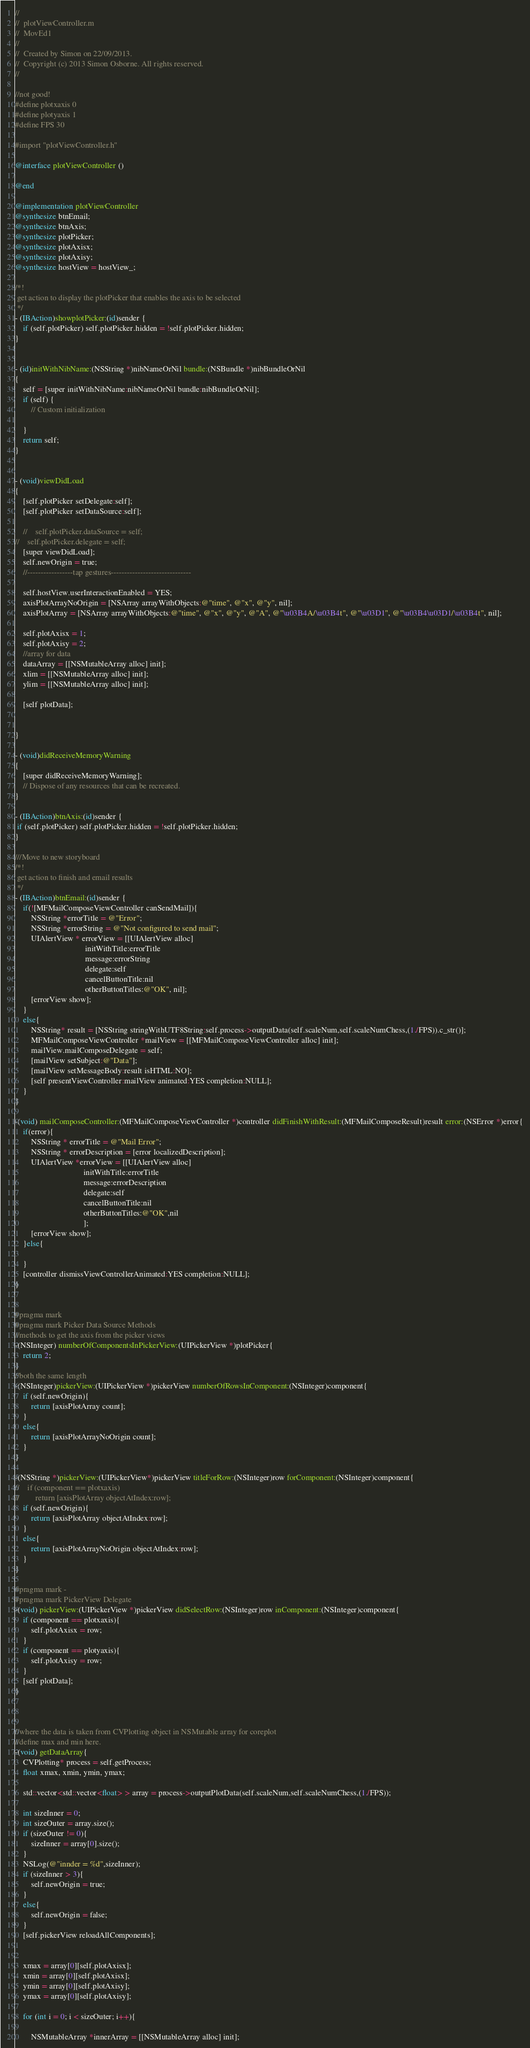<code> <loc_0><loc_0><loc_500><loc_500><_ObjectiveC_>//
//  plotViewController.m
//  MovEd1
//
//  Created by Simon on 22/09/2013.
//  Copyright (c) 2013 Simon Osborne. All rights reserved.
//

//not good!
#define plotxaxis 0
#define plotyaxis 1
#define FPS 30

#import "plotViewController.h"

@interface plotViewController ()

@end

@implementation plotViewController
@synthesize btnEmail;
@synthesize btnAxis;
@synthesize plotPicker;
@synthesize plotAxisx;
@synthesize plotAxisy;
@synthesize hostView = hostView_;

/*!
 get action to display the plotPicker that enables the axis to be selected
 */
- (IBAction)showplotPicker:(id)sender {
    if (self.plotPicker) self.plotPicker.hidden = !self.plotPicker.hidden;
}


- (id)initWithNibName:(NSString *)nibNameOrNil bundle:(NSBundle *)nibBundleOrNil
{
    self = [super initWithNibName:nibNameOrNil bundle:nibBundleOrNil];
    if (self) {
        // Custom initialization

    }
    return self;
}


- (void)viewDidLoad
{
    [self.plotPicker setDelegate:self];
    [self.plotPicker setDataSource:self];

    //    self.plotPicker.dataSource = self;
//    self.plotPicker.delegate = self;
    [super viewDidLoad];
    self.newOrigin = true;
    //-----------------tap gestures------------------------------
    
    self.hostView.userInteractionEnabled = YES;
    axisPlotArrayNoOrigin = [NSArray arrayWithObjects:@"time", @"x", @"y", nil];
    axisPlotArray = [NSArray arrayWithObjects:@"time", @"x", @"y", @"A", @"\u03B4A/\u03B4t", @"\u03D1", @"\u03B4\u03D1/\u03B4t", nil];
    
    self.plotAxisx = 1;
    self.plotAxisy = 2;
    //array for data
    dataArray = [[NSMutableArray alloc] init];
    xlim = [[NSMutableArray alloc] init];
    ylim = [[NSMutableArray alloc] init];

    [self plotData];
    

}

- (void)didReceiveMemoryWarning
{
    [super didReceiveMemoryWarning];
    // Dispose of any resources that can be recreated.
}

- (IBAction)btnAxis:(id)sender {
 if (self.plotPicker) self.plotPicker.hidden = !self.plotPicker.hidden;
}

///Move to new storyboard
/*!
 get action to finish and email results
 */
- (IBAction)btnEmail:(id)sender {
    if(![MFMailComposeViewController canSendMail]){
        NSString *errorTitle = @"Error";
        NSString *errorString = @"Not configured to send mail";
        UIAlertView * errorView = [[UIAlertView alloc]
                                   initWithTitle:errorTitle
                                   message:errorString
                                   delegate:self
                                   cancelButtonTitle:nil
                                   otherButtonTitles:@"OK", nil];
        [errorView show];
    }
    else{
        NSString* result = [NSString stringWithUTF8String:self.process->outputData(self.scaleNum,self.scaleNumChess,(1./FPS)).c_str()];
        MFMailComposeViewController *mailView = [[MFMailComposeViewController alloc] init];
        mailView.mailComposeDelegate = self;
        [mailView setSubject:@"Data"];
        [mailView setMessageBody:result isHTML:NO];
        [self presentViewController:mailView animated:YES completion:NULL];
    }
}

-(void) mailComposeController:(MFMailComposeViewController *)controller didFinishWithResult:(MFMailComposeResult)result error:(NSError *)error{
    if(error){
        NSString * errorTitle = @"Mail Error";
        NSString * errorDescription = [error localizedDescription];
        UIAlertView *errorView = [[UIAlertView alloc]
                                  initWithTitle:errorTitle
                                  message:errorDescription
                                  delegate:self
                                  cancelButtonTitle:nil
                                  otherButtonTitles:@"OK",nil
                                  ];
        [errorView show];
    }else{
        
    }
    [controller dismissViewControllerAnimated:YES completion:NULL];
}


#pragma mark
#pragma mark Picker Data Source Methods
//methods to get the axis from the picker views
-(NSInteger) numberOfComponentsInPickerView:(UIPickerView *)plotPicker{
    return 2;
}
//both the same length
-(NSInteger)pickerView:(UIPickerView *)pickerView numberOfRowsInComponent:(NSInteger)component{
    if (self.newOrigin){
        return [axisPlotArray count];
    }
    else{
        return [axisPlotArrayNoOrigin count];
    }
}

-(NSString *)pickerView:(UIPickerView*)pickerView titleForRow:(NSInteger)row forComponent:(NSInteger)component{
//    if (component == plotxaxis)
//        return [axisPlotArray objectAtIndex:row];
    if (self.newOrigin){
        return [axisPlotArray objectAtIndex:row];
    }
    else{
        return [axisPlotArrayNoOrigin objectAtIndex:row];
    }
}

#pragma mark -
#pragma mark PickerView Delegate
-(void) pickerView:(UIPickerView *)pickerView didSelectRow:(NSInteger)row inComponent:(NSInteger)component{
    if (component == plotxaxis){
        self.plotAxisx = row;
    }
    if (component == plotyaxis){
        self.plotAxisy = row;
    }
    [self plotData];
}



//where the data is taken from CVPlotting object in NSMutable array for coreplot
//define max and min here.
-(void) getDataArray{
    CVPlotting* process = self.getProcess;
    float xmax, xmin, ymin, ymax;
    
    std::vector<std::vector<float> > array = process->outputPlotData(self.scaleNum,self.scaleNumChess,(1./FPS));
    
    int sizeInner = 0;
    int sizeOuter = array.size();
    if (sizeOuter != 0){
        sizeInner = array[0].size();
    }
    NSLog(@"innder = %d",sizeInner);
    if (sizeInner > 3){
        self.newOrigin = true;
    }
    else{
        self.newOrigin = false;
    }
    [self.pickerView reloadAllComponents];

    
    xmax = array[0][self.plotAxisx];
    xmin = array[0][self.plotAxisx];
    ymin = array[0][self.plotAxisy];
    ymax = array[0][self.plotAxisy];
    
    for (int i = 0; i < sizeOuter; i++){
        
        NSMutableArray *innerArray = [[NSMutableArray alloc] init];</code> 